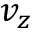<formula> <loc_0><loc_0><loc_500><loc_500>v _ { z }</formula> 